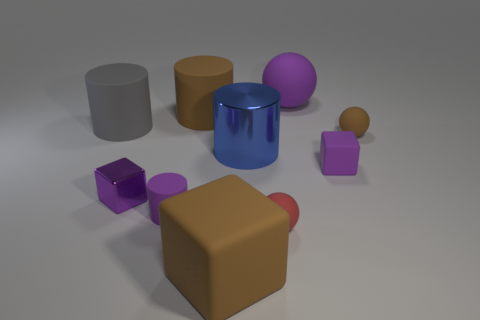Subtract all metallic cubes. How many cubes are left? 2 Subtract all green cylinders. How many purple cubes are left? 2 Subtract all blue cylinders. How many cylinders are left? 3 Subtract all cylinders. How many objects are left? 6 Subtract all yellow cylinders. Subtract all blue blocks. How many cylinders are left? 4 Subtract all purple balls. Subtract all purple balls. How many objects are left? 8 Add 6 small purple things. How many small purple things are left? 9 Add 5 big purple spheres. How many big purple spheres exist? 6 Subtract 0 yellow blocks. How many objects are left? 10 